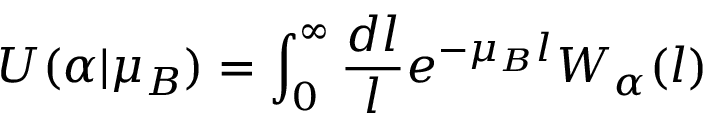Convert formula to latex. <formula><loc_0><loc_0><loc_500><loc_500>U ( \alpha | \mu _ { B } ) = \int _ { 0 } ^ { \infty } \frac { d l } { l } e ^ { - \mu _ { B } l } W _ { \alpha } ( l )</formula> 